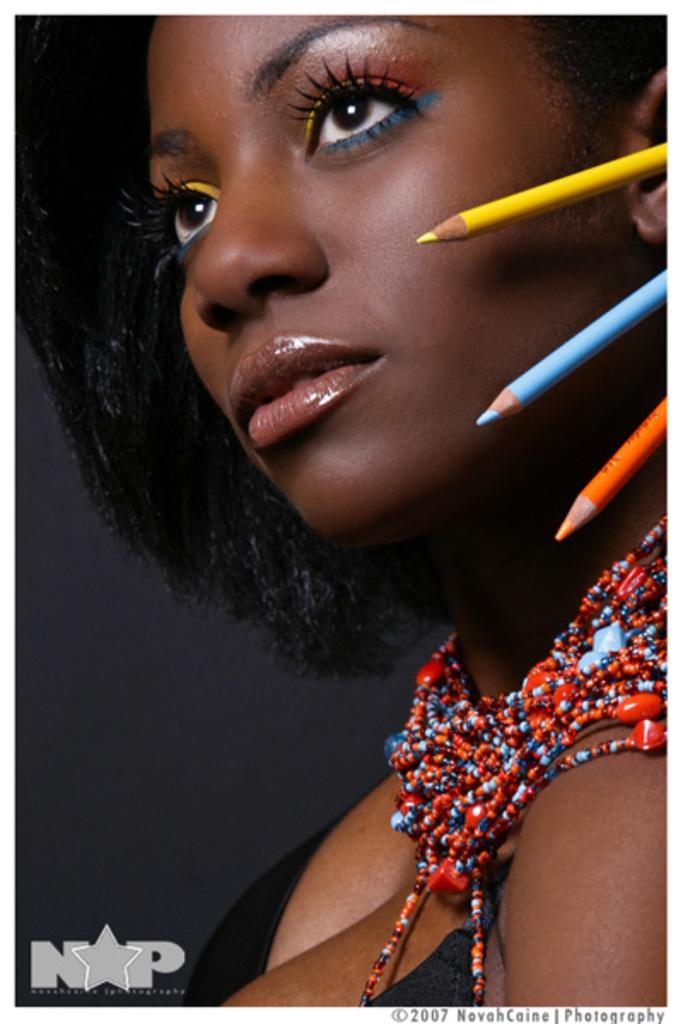What can be seen in the background of the image? There is a wall in the image. Who is present in the image? There is a woman in the image. What is the woman wearing? The woman is wearing a black dress. What objects can be seen in the image besides the woman? There are color pencils in the image. What type of disease is the woman suffering from in the image? There is no indication of any disease in the image; the woman is simply wearing a black dress and standing near color pencils. Is the woman in jail in the image? There is no indication of a jail or any confinement in the image; the woman is standing near a wall and color pencils. 